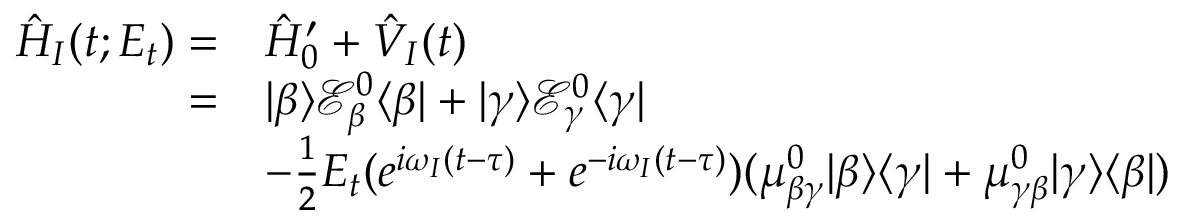Convert formula to latex. <formula><loc_0><loc_0><loc_500><loc_500>\begin{array} { r l } { \hat { H } _ { I } ( t ; E _ { t } ) = } & { \hat { H } _ { 0 } ^ { \prime } + \hat { V } _ { I } ( t ) } \\ { = } & { | \beta \rangle \mathcal { E } _ { \beta } ^ { 0 } \langle \beta | + | \gamma \rangle \mathcal { E } _ { \gamma } ^ { 0 } \langle \gamma | } \\ & { - \frac { 1 } { 2 } E _ { t } ( e ^ { i \omega _ { I } ( t - \tau ) } + e ^ { - i \omega _ { I } ( t - \tau ) } ) ( \mu _ { \beta \gamma } ^ { 0 } | \beta \rangle \langle \gamma | + \mu _ { \gamma \beta } ^ { 0 } | \gamma \rangle \langle \beta | ) } \end{array}</formula> 